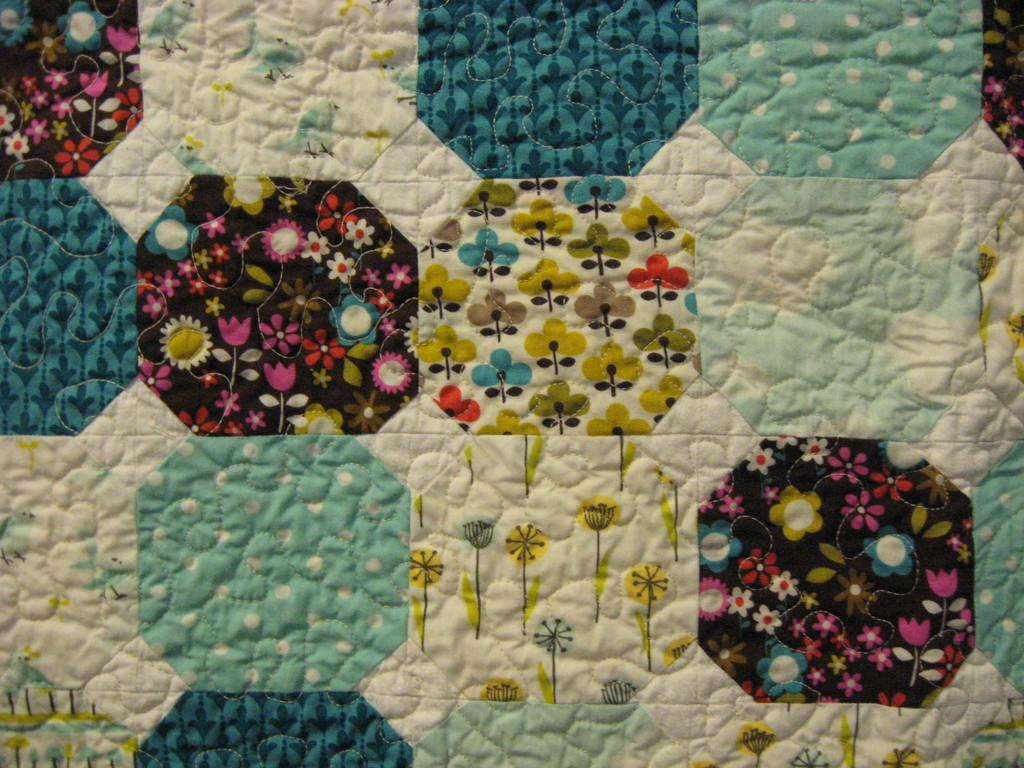How does the mist balance the cream in the image? There is no mist or cream present in the image, so it is not possible to determine how they might balance each other. 